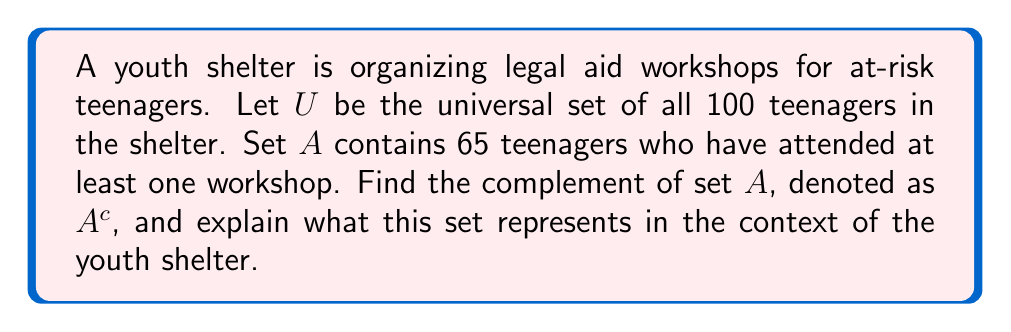Provide a solution to this math problem. To solve this problem, we need to understand the concept of complement in set theory:

1) The complement of a set $A$, denoted as $A^c$, is the set of all elements in the universal set $U$ that are not in $A$.

2) Mathematically, this is expressed as: $A^c = U \setminus A$, where $\setminus$ represents the set difference operation.

3) In this case:
   $U$ = 100 (total number of teenagers in the shelter)
   $|A|$ = 65 (number of teenagers who attended at least one workshop)

4) To find $|A^c|$, we subtract $|A|$ from $|U|$:
   $|A^c| = |U| - |A| = 100 - 65 = 35$

5) Therefore, $A^c$ contains 35 teenagers.

In the context of the youth shelter, $A^c$ represents the set of teenagers who have not attended any legal aid workshops. This information could be valuable for the youth shelter coordinator to identify which teenagers might need additional encouragement or support to participate in future workshops.
Answer: $A^c$ contains 35 teenagers who have not attended any legal aid workshops. 